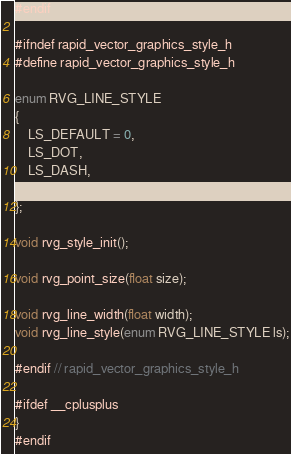Convert code to text. <code><loc_0><loc_0><loc_500><loc_500><_C_>#endif

#ifndef rapid_vector_graphics_style_h
#define rapid_vector_graphics_style_h

enum RVG_LINE_STYLE
{
	LS_DEFAULT = 0,
	LS_DOT,
	LS_DASH,
	LS_DOT_DASH
};

void rvg_style_init();

void rvg_point_size(float size);

void rvg_line_width(float width);
void rvg_line_style(enum RVG_LINE_STYLE ls);

#endif // rapid_vector_graphics_style_h

#ifdef __cplusplus
}
#endif</code> 